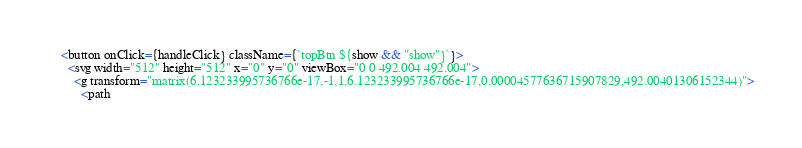<code> <loc_0><loc_0><loc_500><loc_500><_JavaScript_>    <button onClick={handleClick} className={`topBtn ${show && "show"}`}>
      <svg width="512" height="512" x="0" y="0" viewBox="0 0 492.004 492.004">
        <g transform="matrix(6.123233995736766e-17,-1,1,6.123233995736766e-17,0.00004577636715907829,492.00401306152344)">
          <path</code> 